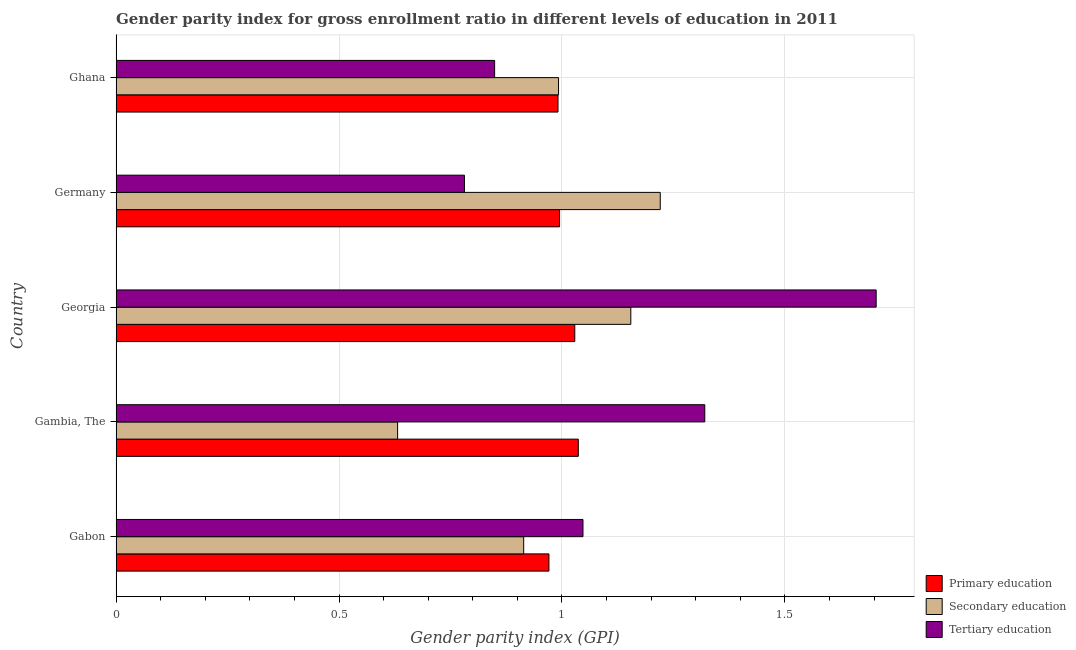How many different coloured bars are there?
Provide a succinct answer. 3. Are the number of bars on each tick of the Y-axis equal?
Provide a short and direct response. Yes. How many bars are there on the 4th tick from the top?
Your answer should be compact. 3. How many bars are there on the 4th tick from the bottom?
Provide a short and direct response. 3. What is the label of the 3rd group of bars from the top?
Provide a succinct answer. Georgia. In how many cases, is the number of bars for a given country not equal to the number of legend labels?
Provide a short and direct response. 0. What is the gender parity index in primary education in Gabon?
Give a very brief answer. 0.97. Across all countries, what is the maximum gender parity index in primary education?
Offer a terse response. 1.04. Across all countries, what is the minimum gender parity index in secondary education?
Keep it short and to the point. 0.63. In which country was the gender parity index in primary education maximum?
Your answer should be very brief. Gambia, The. In which country was the gender parity index in primary education minimum?
Your answer should be compact. Gabon. What is the total gender parity index in secondary education in the graph?
Make the answer very short. 4.91. What is the difference between the gender parity index in secondary education in Gambia, The and that in Ghana?
Your answer should be very brief. -0.36. What is the difference between the gender parity index in secondary education in Gambia, The and the gender parity index in tertiary education in Germany?
Provide a short and direct response. -0.15. What is the average gender parity index in tertiary education per country?
Keep it short and to the point. 1.14. In how many countries, is the gender parity index in secondary education greater than 0.30000000000000004 ?
Ensure brevity in your answer.  5. Is the gender parity index in secondary education in Georgia less than that in Germany?
Offer a terse response. Yes. What is the difference between the highest and the second highest gender parity index in secondary education?
Keep it short and to the point. 0.07. What does the 1st bar from the top in Ghana represents?
Offer a terse response. Tertiary education. What does the 2nd bar from the bottom in Gabon represents?
Ensure brevity in your answer.  Secondary education. What is the difference between two consecutive major ticks on the X-axis?
Your response must be concise. 0.5. Are the values on the major ticks of X-axis written in scientific E-notation?
Your response must be concise. No. Does the graph contain any zero values?
Ensure brevity in your answer.  No. Does the graph contain grids?
Offer a very short reply. Yes. Where does the legend appear in the graph?
Your answer should be compact. Bottom right. How are the legend labels stacked?
Ensure brevity in your answer.  Vertical. What is the title of the graph?
Keep it short and to the point. Gender parity index for gross enrollment ratio in different levels of education in 2011. What is the label or title of the X-axis?
Your response must be concise. Gender parity index (GPI). What is the Gender parity index (GPI) in Primary education in Gabon?
Provide a succinct answer. 0.97. What is the Gender parity index (GPI) of Secondary education in Gabon?
Your response must be concise. 0.91. What is the Gender parity index (GPI) in Tertiary education in Gabon?
Keep it short and to the point. 1.05. What is the Gender parity index (GPI) in Primary education in Gambia, The?
Make the answer very short. 1.04. What is the Gender parity index (GPI) in Secondary education in Gambia, The?
Provide a succinct answer. 0.63. What is the Gender parity index (GPI) of Tertiary education in Gambia, The?
Offer a terse response. 1.32. What is the Gender parity index (GPI) in Primary education in Georgia?
Your response must be concise. 1.03. What is the Gender parity index (GPI) in Secondary education in Georgia?
Make the answer very short. 1.15. What is the Gender parity index (GPI) of Tertiary education in Georgia?
Your answer should be compact. 1.7. What is the Gender parity index (GPI) of Primary education in Germany?
Ensure brevity in your answer.  0.99. What is the Gender parity index (GPI) of Secondary education in Germany?
Offer a terse response. 1.22. What is the Gender parity index (GPI) of Tertiary education in Germany?
Offer a terse response. 0.78. What is the Gender parity index (GPI) of Primary education in Ghana?
Provide a short and direct response. 0.99. What is the Gender parity index (GPI) of Secondary education in Ghana?
Ensure brevity in your answer.  0.99. What is the Gender parity index (GPI) in Tertiary education in Ghana?
Offer a terse response. 0.85. Across all countries, what is the maximum Gender parity index (GPI) of Primary education?
Your answer should be very brief. 1.04. Across all countries, what is the maximum Gender parity index (GPI) in Secondary education?
Offer a terse response. 1.22. Across all countries, what is the maximum Gender parity index (GPI) of Tertiary education?
Offer a very short reply. 1.7. Across all countries, what is the minimum Gender parity index (GPI) in Primary education?
Provide a short and direct response. 0.97. Across all countries, what is the minimum Gender parity index (GPI) in Secondary education?
Your response must be concise. 0.63. Across all countries, what is the minimum Gender parity index (GPI) in Tertiary education?
Provide a succinct answer. 0.78. What is the total Gender parity index (GPI) of Primary education in the graph?
Provide a succinct answer. 5.02. What is the total Gender parity index (GPI) of Secondary education in the graph?
Make the answer very short. 4.91. What is the total Gender parity index (GPI) of Tertiary education in the graph?
Your answer should be very brief. 5.7. What is the difference between the Gender parity index (GPI) of Primary education in Gabon and that in Gambia, The?
Your response must be concise. -0.07. What is the difference between the Gender parity index (GPI) of Secondary education in Gabon and that in Gambia, The?
Your answer should be compact. 0.28. What is the difference between the Gender parity index (GPI) in Tertiary education in Gabon and that in Gambia, The?
Offer a terse response. -0.27. What is the difference between the Gender parity index (GPI) of Primary education in Gabon and that in Georgia?
Offer a very short reply. -0.06. What is the difference between the Gender parity index (GPI) in Secondary education in Gabon and that in Georgia?
Give a very brief answer. -0.24. What is the difference between the Gender parity index (GPI) of Tertiary education in Gabon and that in Georgia?
Provide a short and direct response. -0.66. What is the difference between the Gender parity index (GPI) in Primary education in Gabon and that in Germany?
Ensure brevity in your answer.  -0.02. What is the difference between the Gender parity index (GPI) of Secondary education in Gabon and that in Germany?
Ensure brevity in your answer.  -0.31. What is the difference between the Gender parity index (GPI) in Tertiary education in Gabon and that in Germany?
Offer a very short reply. 0.27. What is the difference between the Gender parity index (GPI) of Primary education in Gabon and that in Ghana?
Keep it short and to the point. -0.02. What is the difference between the Gender parity index (GPI) in Secondary education in Gabon and that in Ghana?
Your answer should be very brief. -0.08. What is the difference between the Gender parity index (GPI) of Tertiary education in Gabon and that in Ghana?
Your answer should be very brief. 0.2. What is the difference between the Gender parity index (GPI) of Primary education in Gambia, The and that in Georgia?
Offer a very short reply. 0.01. What is the difference between the Gender parity index (GPI) in Secondary education in Gambia, The and that in Georgia?
Give a very brief answer. -0.52. What is the difference between the Gender parity index (GPI) of Tertiary education in Gambia, The and that in Georgia?
Keep it short and to the point. -0.38. What is the difference between the Gender parity index (GPI) in Primary education in Gambia, The and that in Germany?
Your answer should be compact. 0.04. What is the difference between the Gender parity index (GPI) of Secondary education in Gambia, The and that in Germany?
Provide a succinct answer. -0.59. What is the difference between the Gender parity index (GPI) in Tertiary education in Gambia, The and that in Germany?
Offer a terse response. 0.54. What is the difference between the Gender parity index (GPI) of Primary education in Gambia, The and that in Ghana?
Ensure brevity in your answer.  0.05. What is the difference between the Gender parity index (GPI) of Secondary education in Gambia, The and that in Ghana?
Provide a short and direct response. -0.36. What is the difference between the Gender parity index (GPI) of Tertiary education in Gambia, The and that in Ghana?
Provide a succinct answer. 0.47. What is the difference between the Gender parity index (GPI) of Primary education in Georgia and that in Germany?
Give a very brief answer. 0.03. What is the difference between the Gender parity index (GPI) of Secondary education in Georgia and that in Germany?
Offer a terse response. -0.07. What is the difference between the Gender parity index (GPI) of Tertiary education in Georgia and that in Germany?
Your response must be concise. 0.92. What is the difference between the Gender parity index (GPI) in Primary education in Georgia and that in Ghana?
Provide a succinct answer. 0.04. What is the difference between the Gender parity index (GPI) of Secondary education in Georgia and that in Ghana?
Your answer should be very brief. 0.16. What is the difference between the Gender parity index (GPI) in Tertiary education in Georgia and that in Ghana?
Offer a very short reply. 0.86. What is the difference between the Gender parity index (GPI) in Primary education in Germany and that in Ghana?
Provide a short and direct response. 0. What is the difference between the Gender parity index (GPI) in Secondary education in Germany and that in Ghana?
Your answer should be very brief. 0.23. What is the difference between the Gender parity index (GPI) in Tertiary education in Germany and that in Ghana?
Your answer should be very brief. -0.07. What is the difference between the Gender parity index (GPI) of Primary education in Gabon and the Gender parity index (GPI) of Secondary education in Gambia, The?
Your response must be concise. 0.34. What is the difference between the Gender parity index (GPI) of Primary education in Gabon and the Gender parity index (GPI) of Tertiary education in Gambia, The?
Give a very brief answer. -0.35. What is the difference between the Gender parity index (GPI) of Secondary education in Gabon and the Gender parity index (GPI) of Tertiary education in Gambia, The?
Your answer should be compact. -0.41. What is the difference between the Gender parity index (GPI) of Primary education in Gabon and the Gender parity index (GPI) of Secondary education in Georgia?
Make the answer very short. -0.18. What is the difference between the Gender parity index (GPI) in Primary education in Gabon and the Gender parity index (GPI) in Tertiary education in Georgia?
Ensure brevity in your answer.  -0.73. What is the difference between the Gender parity index (GPI) in Secondary education in Gabon and the Gender parity index (GPI) in Tertiary education in Georgia?
Your answer should be very brief. -0.79. What is the difference between the Gender parity index (GPI) of Primary education in Gabon and the Gender parity index (GPI) of Secondary education in Germany?
Offer a very short reply. -0.25. What is the difference between the Gender parity index (GPI) of Primary education in Gabon and the Gender parity index (GPI) of Tertiary education in Germany?
Provide a short and direct response. 0.19. What is the difference between the Gender parity index (GPI) of Secondary education in Gabon and the Gender parity index (GPI) of Tertiary education in Germany?
Offer a very short reply. 0.13. What is the difference between the Gender parity index (GPI) in Primary education in Gabon and the Gender parity index (GPI) in Secondary education in Ghana?
Provide a short and direct response. -0.02. What is the difference between the Gender parity index (GPI) of Primary education in Gabon and the Gender parity index (GPI) of Tertiary education in Ghana?
Provide a succinct answer. 0.12. What is the difference between the Gender parity index (GPI) of Secondary education in Gabon and the Gender parity index (GPI) of Tertiary education in Ghana?
Ensure brevity in your answer.  0.07. What is the difference between the Gender parity index (GPI) of Primary education in Gambia, The and the Gender parity index (GPI) of Secondary education in Georgia?
Your answer should be very brief. -0.12. What is the difference between the Gender parity index (GPI) of Primary education in Gambia, The and the Gender parity index (GPI) of Tertiary education in Georgia?
Provide a short and direct response. -0.67. What is the difference between the Gender parity index (GPI) in Secondary education in Gambia, The and the Gender parity index (GPI) in Tertiary education in Georgia?
Give a very brief answer. -1.07. What is the difference between the Gender parity index (GPI) of Primary education in Gambia, The and the Gender parity index (GPI) of Secondary education in Germany?
Your response must be concise. -0.18. What is the difference between the Gender parity index (GPI) of Primary education in Gambia, The and the Gender parity index (GPI) of Tertiary education in Germany?
Your response must be concise. 0.26. What is the difference between the Gender parity index (GPI) of Secondary education in Gambia, The and the Gender parity index (GPI) of Tertiary education in Germany?
Give a very brief answer. -0.15. What is the difference between the Gender parity index (GPI) in Primary education in Gambia, The and the Gender parity index (GPI) in Secondary education in Ghana?
Keep it short and to the point. 0.04. What is the difference between the Gender parity index (GPI) in Primary education in Gambia, The and the Gender parity index (GPI) in Tertiary education in Ghana?
Offer a very short reply. 0.19. What is the difference between the Gender parity index (GPI) in Secondary education in Gambia, The and the Gender parity index (GPI) in Tertiary education in Ghana?
Provide a short and direct response. -0.22. What is the difference between the Gender parity index (GPI) of Primary education in Georgia and the Gender parity index (GPI) of Secondary education in Germany?
Offer a very short reply. -0.19. What is the difference between the Gender parity index (GPI) of Primary education in Georgia and the Gender parity index (GPI) of Tertiary education in Germany?
Your answer should be very brief. 0.25. What is the difference between the Gender parity index (GPI) in Secondary education in Georgia and the Gender parity index (GPI) in Tertiary education in Germany?
Provide a succinct answer. 0.37. What is the difference between the Gender parity index (GPI) of Primary education in Georgia and the Gender parity index (GPI) of Secondary education in Ghana?
Provide a succinct answer. 0.04. What is the difference between the Gender parity index (GPI) in Primary education in Georgia and the Gender parity index (GPI) in Tertiary education in Ghana?
Offer a terse response. 0.18. What is the difference between the Gender parity index (GPI) of Secondary education in Georgia and the Gender parity index (GPI) of Tertiary education in Ghana?
Provide a succinct answer. 0.31. What is the difference between the Gender parity index (GPI) of Primary education in Germany and the Gender parity index (GPI) of Secondary education in Ghana?
Provide a short and direct response. 0. What is the difference between the Gender parity index (GPI) in Primary education in Germany and the Gender parity index (GPI) in Tertiary education in Ghana?
Your response must be concise. 0.15. What is the difference between the Gender parity index (GPI) in Secondary education in Germany and the Gender parity index (GPI) in Tertiary education in Ghana?
Your response must be concise. 0.37. What is the average Gender parity index (GPI) of Primary education per country?
Your response must be concise. 1. What is the average Gender parity index (GPI) in Secondary education per country?
Your answer should be very brief. 0.98. What is the average Gender parity index (GPI) of Tertiary education per country?
Ensure brevity in your answer.  1.14. What is the difference between the Gender parity index (GPI) in Primary education and Gender parity index (GPI) in Secondary education in Gabon?
Provide a succinct answer. 0.06. What is the difference between the Gender parity index (GPI) in Primary education and Gender parity index (GPI) in Tertiary education in Gabon?
Keep it short and to the point. -0.08. What is the difference between the Gender parity index (GPI) in Secondary education and Gender parity index (GPI) in Tertiary education in Gabon?
Keep it short and to the point. -0.13. What is the difference between the Gender parity index (GPI) in Primary education and Gender parity index (GPI) in Secondary education in Gambia, The?
Ensure brevity in your answer.  0.41. What is the difference between the Gender parity index (GPI) of Primary education and Gender parity index (GPI) of Tertiary education in Gambia, The?
Offer a very short reply. -0.28. What is the difference between the Gender parity index (GPI) of Secondary education and Gender parity index (GPI) of Tertiary education in Gambia, The?
Give a very brief answer. -0.69. What is the difference between the Gender parity index (GPI) in Primary education and Gender parity index (GPI) in Secondary education in Georgia?
Give a very brief answer. -0.13. What is the difference between the Gender parity index (GPI) in Primary education and Gender parity index (GPI) in Tertiary education in Georgia?
Ensure brevity in your answer.  -0.68. What is the difference between the Gender parity index (GPI) in Secondary education and Gender parity index (GPI) in Tertiary education in Georgia?
Make the answer very short. -0.55. What is the difference between the Gender parity index (GPI) of Primary education and Gender parity index (GPI) of Secondary education in Germany?
Keep it short and to the point. -0.23. What is the difference between the Gender parity index (GPI) in Primary education and Gender parity index (GPI) in Tertiary education in Germany?
Keep it short and to the point. 0.21. What is the difference between the Gender parity index (GPI) of Secondary education and Gender parity index (GPI) of Tertiary education in Germany?
Your answer should be compact. 0.44. What is the difference between the Gender parity index (GPI) in Primary education and Gender parity index (GPI) in Secondary education in Ghana?
Offer a very short reply. -0. What is the difference between the Gender parity index (GPI) of Primary education and Gender parity index (GPI) of Tertiary education in Ghana?
Give a very brief answer. 0.14. What is the difference between the Gender parity index (GPI) in Secondary education and Gender parity index (GPI) in Tertiary education in Ghana?
Your answer should be compact. 0.14. What is the ratio of the Gender parity index (GPI) in Primary education in Gabon to that in Gambia, The?
Provide a succinct answer. 0.94. What is the ratio of the Gender parity index (GPI) of Secondary education in Gabon to that in Gambia, The?
Your response must be concise. 1.45. What is the ratio of the Gender parity index (GPI) in Tertiary education in Gabon to that in Gambia, The?
Make the answer very short. 0.79. What is the ratio of the Gender parity index (GPI) of Primary education in Gabon to that in Georgia?
Make the answer very short. 0.94. What is the ratio of the Gender parity index (GPI) of Secondary education in Gabon to that in Georgia?
Provide a short and direct response. 0.79. What is the ratio of the Gender parity index (GPI) in Tertiary education in Gabon to that in Georgia?
Keep it short and to the point. 0.61. What is the ratio of the Gender parity index (GPI) of Primary education in Gabon to that in Germany?
Offer a very short reply. 0.98. What is the ratio of the Gender parity index (GPI) in Secondary education in Gabon to that in Germany?
Your answer should be compact. 0.75. What is the ratio of the Gender parity index (GPI) in Tertiary education in Gabon to that in Germany?
Make the answer very short. 1.34. What is the ratio of the Gender parity index (GPI) in Primary education in Gabon to that in Ghana?
Offer a terse response. 0.98. What is the ratio of the Gender parity index (GPI) in Secondary education in Gabon to that in Ghana?
Make the answer very short. 0.92. What is the ratio of the Gender parity index (GPI) of Tertiary education in Gabon to that in Ghana?
Your answer should be very brief. 1.23. What is the ratio of the Gender parity index (GPI) of Primary education in Gambia, The to that in Georgia?
Offer a very short reply. 1.01. What is the ratio of the Gender parity index (GPI) of Secondary education in Gambia, The to that in Georgia?
Give a very brief answer. 0.55. What is the ratio of the Gender parity index (GPI) of Tertiary education in Gambia, The to that in Georgia?
Your answer should be very brief. 0.77. What is the ratio of the Gender parity index (GPI) in Primary education in Gambia, The to that in Germany?
Offer a terse response. 1.04. What is the ratio of the Gender parity index (GPI) of Secondary education in Gambia, The to that in Germany?
Offer a terse response. 0.52. What is the ratio of the Gender parity index (GPI) of Tertiary education in Gambia, The to that in Germany?
Offer a terse response. 1.69. What is the ratio of the Gender parity index (GPI) in Primary education in Gambia, The to that in Ghana?
Make the answer very short. 1.05. What is the ratio of the Gender parity index (GPI) of Secondary education in Gambia, The to that in Ghana?
Give a very brief answer. 0.64. What is the ratio of the Gender parity index (GPI) in Tertiary education in Gambia, The to that in Ghana?
Make the answer very short. 1.56. What is the ratio of the Gender parity index (GPI) of Primary education in Georgia to that in Germany?
Keep it short and to the point. 1.03. What is the ratio of the Gender parity index (GPI) of Secondary education in Georgia to that in Germany?
Make the answer very short. 0.95. What is the ratio of the Gender parity index (GPI) of Tertiary education in Georgia to that in Germany?
Your answer should be compact. 2.18. What is the ratio of the Gender parity index (GPI) in Primary education in Georgia to that in Ghana?
Ensure brevity in your answer.  1.04. What is the ratio of the Gender parity index (GPI) in Secondary education in Georgia to that in Ghana?
Your response must be concise. 1.16. What is the ratio of the Gender parity index (GPI) in Tertiary education in Georgia to that in Ghana?
Keep it short and to the point. 2.01. What is the ratio of the Gender parity index (GPI) of Primary education in Germany to that in Ghana?
Keep it short and to the point. 1. What is the ratio of the Gender parity index (GPI) of Secondary education in Germany to that in Ghana?
Offer a very short reply. 1.23. What is the ratio of the Gender parity index (GPI) in Tertiary education in Germany to that in Ghana?
Make the answer very short. 0.92. What is the difference between the highest and the second highest Gender parity index (GPI) of Primary education?
Ensure brevity in your answer.  0.01. What is the difference between the highest and the second highest Gender parity index (GPI) of Secondary education?
Offer a terse response. 0.07. What is the difference between the highest and the second highest Gender parity index (GPI) in Tertiary education?
Provide a short and direct response. 0.38. What is the difference between the highest and the lowest Gender parity index (GPI) in Primary education?
Provide a succinct answer. 0.07. What is the difference between the highest and the lowest Gender parity index (GPI) of Secondary education?
Provide a succinct answer. 0.59. What is the difference between the highest and the lowest Gender parity index (GPI) of Tertiary education?
Your answer should be compact. 0.92. 